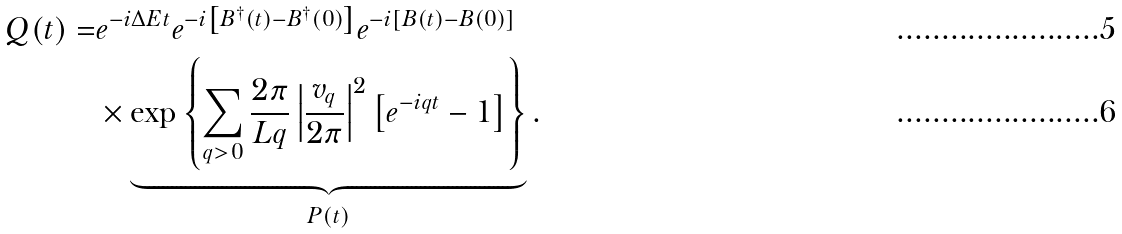Convert formula to latex. <formula><loc_0><loc_0><loc_500><loc_500>Q ( t ) = & e ^ { - i \Delta E t } e ^ { - i \left [ B ^ { \dagger } ( t ) - B ^ { \dagger } ( 0 ) \right ] } e ^ { - i \left [ B ( t ) - B ( 0 ) \right ] } \\ & \times \underbrace { \exp \left \{ \sum _ { q > 0 } \frac { 2 \pi } { L q } \left | \frac { v _ { q } } { 2 \pi } \right | ^ { 2 } \left [ e ^ { - i q t } - 1 \right ] \right \} } _ { P ( t ) } .</formula> 